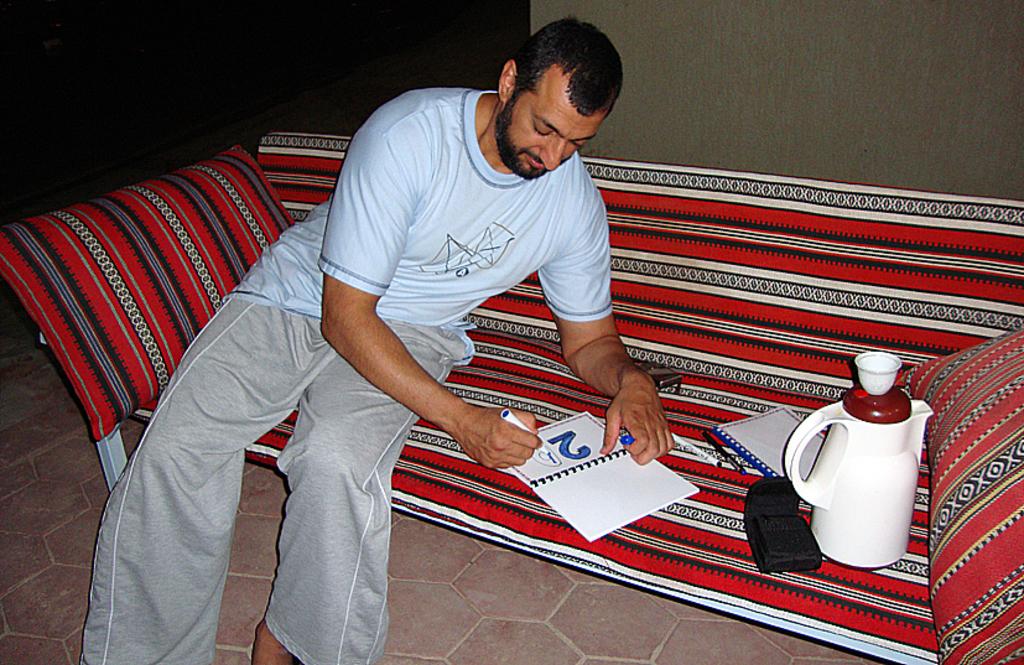What number has already been colored in?
Keep it short and to the point. 2. 